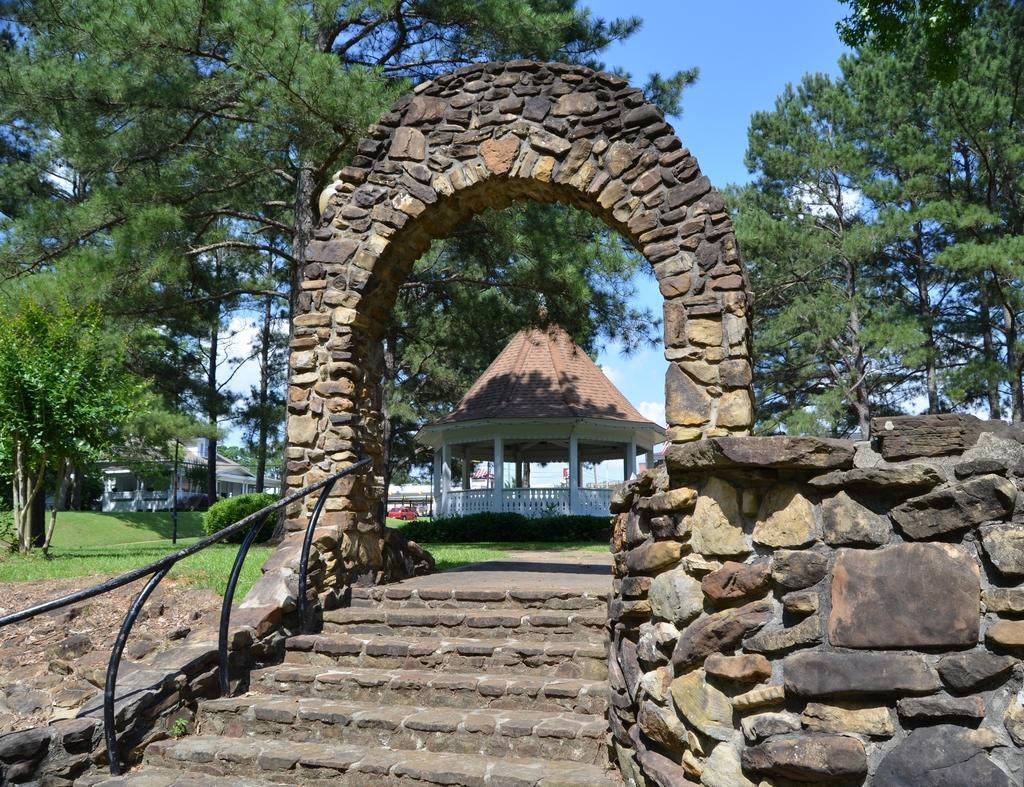Describe this image in one or two sentences. In this image there is the sky, there are buildings, there are trees truncated towards the right of the image, there are trees truncated towards the left of the image, there is a plant, there is the grass, there is an arch made of stones, there is a staircase, there is a wall truncated towards the right of the image, there is a car. 